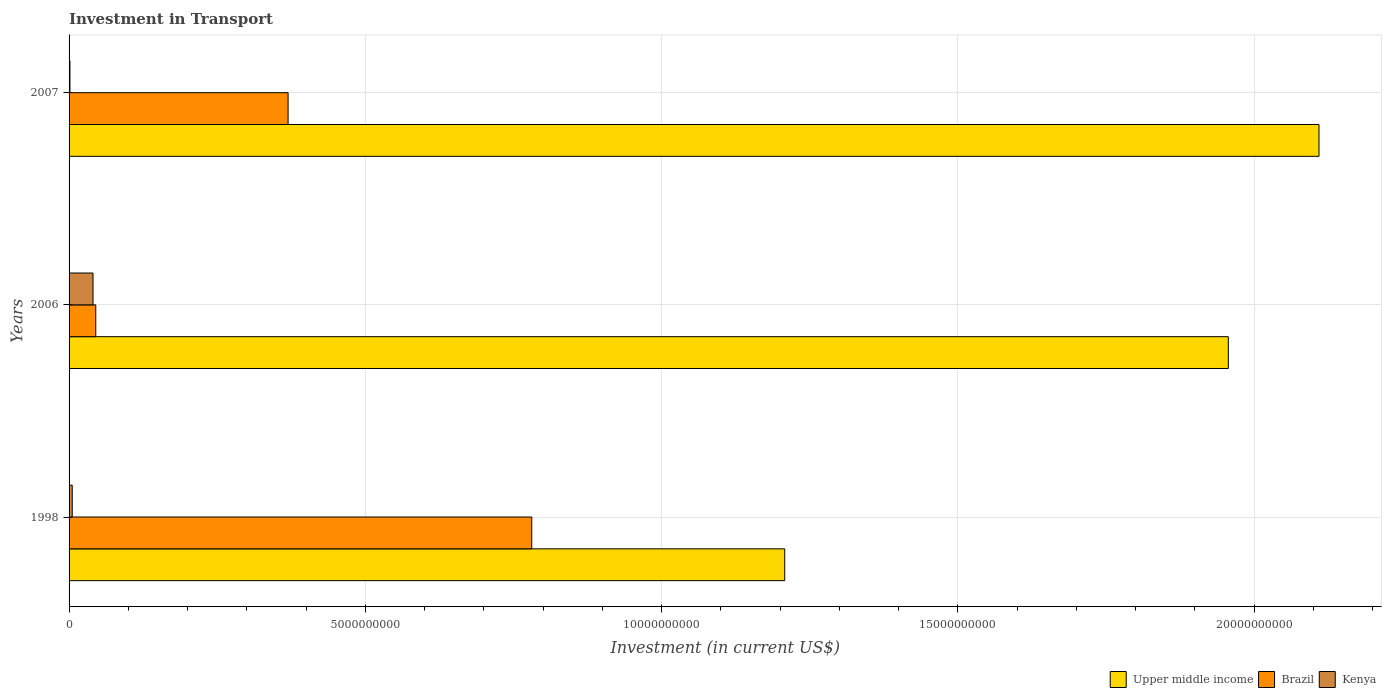How many different coloured bars are there?
Offer a terse response. 3. How many groups of bars are there?
Provide a succinct answer. 3. What is the label of the 2nd group of bars from the top?
Your answer should be compact. 2006. What is the amount invested in transport in Brazil in 2006?
Provide a short and direct response. 4.50e+08. Across all years, what is the maximum amount invested in transport in Brazil?
Give a very brief answer. 7.81e+09. Across all years, what is the minimum amount invested in transport in Brazil?
Keep it short and to the point. 4.50e+08. In which year was the amount invested in transport in Brazil minimum?
Make the answer very short. 2006. What is the total amount invested in transport in Upper middle income in the graph?
Your answer should be very brief. 5.27e+1. What is the difference between the amount invested in transport in Brazil in 1998 and that in 2006?
Give a very brief answer. 7.36e+09. What is the difference between the amount invested in transport in Kenya in 1998 and the amount invested in transport in Upper middle income in 2007?
Your response must be concise. -2.10e+1. What is the average amount invested in transport in Upper middle income per year?
Provide a short and direct response. 1.76e+1. In the year 2007, what is the difference between the amount invested in transport in Upper middle income and amount invested in transport in Kenya?
Make the answer very short. 2.11e+1. In how many years, is the amount invested in transport in Upper middle income greater than 10000000000 US$?
Make the answer very short. 3. What is the ratio of the amount invested in transport in Upper middle income in 2006 to that in 2007?
Offer a terse response. 0.93. Is the amount invested in transport in Brazil in 1998 less than that in 2006?
Provide a succinct answer. No. What is the difference between the highest and the second highest amount invested in transport in Upper middle income?
Provide a succinct answer. 1.53e+09. What is the difference between the highest and the lowest amount invested in transport in Kenya?
Ensure brevity in your answer.  3.89e+08. What does the 3rd bar from the top in 1998 represents?
Provide a short and direct response. Upper middle income. What does the 3rd bar from the bottom in 1998 represents?
Your answer should be compact. Kenya. Is it the case that in every year, the sum of the amount invested in transport in Brazil and amount invested in transport in Kenya is greater than the amount invested in transport in Upper middle income?
Provide a succinct answer. No. How many bars are there?
Your answer should be compact. 9. Are all the bars in the graph horizontal?
Your response must be concise. Yes. How many years are there in the graph?
Your answer should be compact. 3. Are the values on the major ticks of X-axis written in scientific E-notation?
Offer a very short reply. No. Does the graph contain grids?
Offer a terse response. Yes. How many legend labels are there?
Your response must be concise. 3. What is the title of the graph?
Ensure brevity in your answer.  Investment in Transport. Does "Vietnam" appear as one of the legend labels in the graph?
Give a very brief answer. No. What is the label or title of the X-axis?
Make the answer very short. Investment (in current US$). What is the Investment (in current US$) in Upper middle income in 1998?
Your answer should be very brief. 1.21e+1. What is the Investment (in current US$) of Brazil in 1998?
Give a very brief answer. 7.81e+09. What is the Investment (in current US$) of Kenya in 1998?
Provide a succinct answer. 5.34e+07. What is the Investment (in current US$) of Upper middle income in 2006?
Offer a terse response. 1.96e+1. What is the Investment (in current US$) of Brazil in 2006?
Offer a very short reply. 4.50e+08. What is the Investment (in current US$) of Kenya in 2006?
Your answer should be very brief. 4.04e+08. What is the Investment (in current US$) in Upper middle income in 2007?
Give a very brief answer. 2.11e+1. What is the Investment (in current US$) in Brazil in 2007?
Keep it short and to the point. 3.70e+09. What is the Investment (in current US$) of Kenya in 2007?
Your response must be concise. 1.50e+07. Across all years, what is the maximum Investment (in current US$) of Upper middle income?
Offer a very short reply. 2.11e+1. Across all years, what is the maximum Investment (in current US$) in Brazil?
Your response must be concise. 7.81e+09. Across all years, what is the maximum Investment (in current US$) of Kenya?
Make the answer very short. 4.04e+08. Across all years, what is the minimum Investment (in current US$) in Upper middle income?
Offer a terse response. 1.21e+1. Across all years, what is the minimum Investment (in current US$) in Brazil?
Offer a terse response. 4.50e+08. Across all years, what is the minimum Investment (in current US$) of Kenya?
Your answer should be compact. 1.50e+07. What is the total Investment (in current US$) in Upper middle income in the graph?
Give a very brief answer. 5.27e+1. What is the total Investment (in current US$) of Brazil in the graph?
Give a very brief answer. 1.20e+1. What is the total Investment (in current US$) in Kenya in the graph?
Your answer should be compact. 4.72e+08. What is the difference between the Investment (in current US$) of Upper middle income in 1998 and that in 2006?
Your answer should be compact. -7.49e+09. What is the difference between the Investment (in current US$) of Brazil in 1998 and that in 2006?
Ensure brevity in your answer.  7.36e+09. What is the difference between the Investment (in current US$) of Kenya in 1998 and that in 2006?
Your answer should be very brief. -3.51e+08. What is the difference between the Investment (in current US$) of Upper middle income in 1998 and that in 2007?
Keep it short and to the point. -9.02e+09. What is the difference between the Investment (in current US$) in Brazil in 1998 and that in 2007?
Provide a short and direct response. 4.11e+09. What is the difference between the Investment (in current US$) of Kenya in 1998 and that in 2007?
Your response must be concise. 3.84e+07. What is the difference between the Investment (in current US$) of Upper middle income in 2006 and that in 2007?
Give a very brief answer. -1.53e+09. What is the difference between the Investment (in current US$) in Brazil in 2006 and that in 2007?
Your answer should be compact. -3.25e+09. What is the difference between the Investment (in current US$) of Kenya in 2006 and that in 2007?
Offer a very short reply. 3.89e+08. What is the difference between the Investment (in current US$) in Upper middle income in 1998 and the Investment (in current US$) in Brazil in 2006?
Offer a terse response. 1.16e+1. What is the difference between the Investment (in current US$) in Upper middle income in 1998 and the Investment (in current US$) in Kenya in 2006?
Ensure brevity in your answer.  1.17e+1. What is the difference between the Investment (in current US$) of Brazil in 1998 and the Investment (in current US$) of Kenya in 2006?
Make the answer very short. 7.40e+09. What is the difference between the Investment (in current US$) of Upper middle income in 1998 and the Investment (in current US$) of Brazil in 2007?
Give a very brief answer. 8.38e+09. What is the difference between the Investment (in current US$) in Upper middle income in 1998 and the Investment (in current US$) in Kenya in 2007?
Provide a succinct answer. 1.21e+1. What is the difference between the Investment (in current US$) of Brazil in 1998 and the Investment (in current US$) of Kenya in 2007?
Make the answer very short. 7.79e+09. What is the difference between the Investment (in current US$) in Upper middle income in 2006 and the Investment (in current US$) in Brazil in 2007?
Your answer should be compact. 1.59e+1. What is the difference between the Investment (in current US$) in Upper middle income in 2006 and the Investment (in current US$) in Kenya in 2007?
Give a very brief answer. 1.95e+1. What is the difference between the Investment (in current US$) of Brazil in 2006 and the Investment (in current US$) of Kenya in 2007?
Give a very brief answer. 4.35e+08. What is the average Investment (in current US$) of Upper middle income per year?
Make the answer very short. 1.76e+1. What is the average Investment (in current US$) of Brazil per year?
Your answer should be very brief. 3.99e+09. What is the average Investment (in current US$) of Kenya per year?
Provide a short and direct response. 1.57e+08. In the year 1998, what is the difference between the Investment (in current US$) in Upper middle income and Investment (in current US$) in Brazil?
Provide a short and direct response. 4.27e+09. In the year 1998, what is the difference between the Investment (in current US$) of Upper middle income and Investment (in current US$) of Kenya?
Keep it short and to the point. 1.20e+1. In the year 1998, what is the difference between the Investment (in current US$) of Brazil and Investment (in current US$) of Kenya?
Offer a terse response. 7.76e+09. In the year 2006, what is the difference between the Investment (in current US$) in Upper middle income and Investment (in current US$) in Brazil?
Provide a short and direct response. 1.91e+1. In the year 2006, what is the difference between the Investment (in current US$) in Upper middle income and Investment (in current US$) in Kenya?
Make the answer very short. 1.92e+1. In the year 2006, what is the difference between the Investment (in current US$) in Brazil and Investment (in current US$) in Kenya?
Your answer should be compact. 4.64e+07. In the year 2007, what is the difference between the Investment (in current US$) of Upper middle income and Investment (in current US$) of Brazil?
Provide a succinct answer. 1.74e+1. In the year 2007, what is the difference between the Investment (in current US$) in Upper middle income and Investment (in current US$) in Kenya?
Your response must be concise. 2.11e+1. In the year 2007, what is the difference between the Investment (in current US$) of Brazil and Investment (in current US$) of Kenya?
Ensure brevity in your answer.  3.68e+09. What is the ratio of the Investment (in current US$) in Upper middle income in 1998 to that in 2006?
Provide a short and direct response. 0.62. What is the ratio of the Investment (in current US$) of Brazil in 1998 to that in 2006?
Give a very brief answer. 17.34. What is the ratio of the Investment (in current US$) in Kenya in 1998 to that in 2006?
Give a very brief answer. 0.13. What is the ratio of the Investment (in current US$) in Upper middle income in 1998 to that in 2007?
Your answer should be compact. 0.57. What is the ratio of the Investment (in current US$) in Brazil in 1998 to that in 2007?
Make the answer very short. 2.11. What is the ratio of the Investment (in current US$) in Kenya in 1998 to that in 2007?
Offer a terse response. 3.56. What is the ratio of the Investment (in current US$) of Upper middle income in 2006 to that in 2007?
Give a very brief answer. 0.93. What is the ratio of the Investment (in current US$) of Brazil in 2006 to that in 2007?
Offer a very short reply. 0.12. What is the ratio of the Investment (in current US$) in Kenya in 2006 to that in 2007?
Provide a short and direct response. 26.93. What is the difference between the highest and the second highest Investment (in current US$) in Upper middle income?
Your answer should be very brief. 1.53e+09. What is the difference between the highest and the second highest Investment (in current US$) in Brazil?
Offer a terse response. 4.11e+09. What is the difference between the highest and the second highest Investment (in current US$) of Kenya?
Ensure brevity in your answer.  3.51e+08. What is the difference between the highest and the lowest Investment (in current US$) of Upper middle income?
Your answer should be compact. 9.02e+09. What is the difference between the highest and the lowest Investment (in current US$) in Brazil?
Your response must be concise. 7.36e+09. What is the difference between the highest and the lowest Investment (in current US$) in Kenya?
Your answer should be very brief. 3.89e+08. 